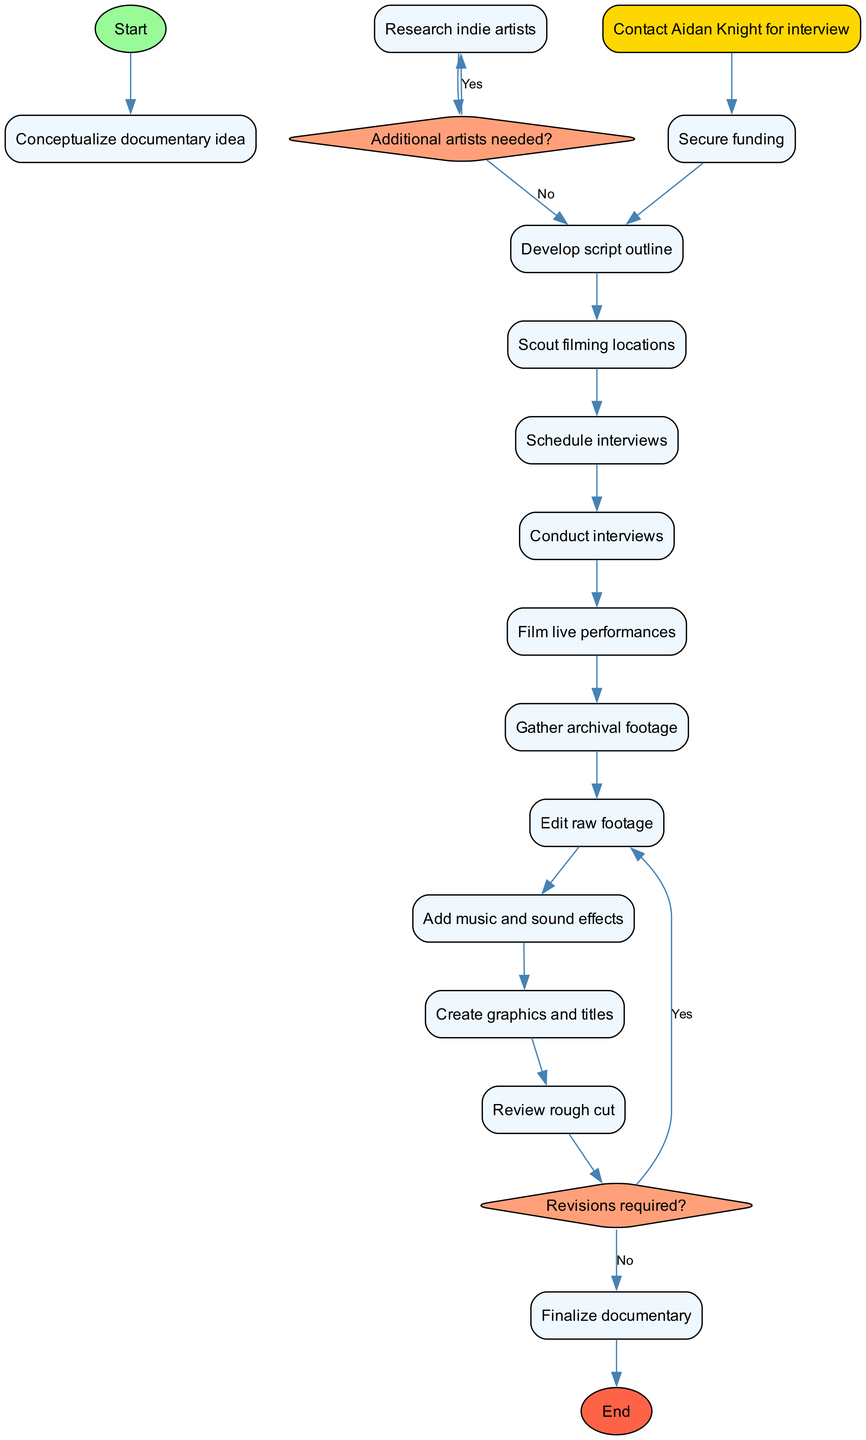What is the first activity listed in the diagram? The diagram starts with the node labeled "Conceptualize documentary idea," indicating that this is the initial step in the process.
Answer: Conceptualize documentary idea How many activities are involved in the process? Counting the activities listed in the diagram, there are a total of 13 distinct activities that need to be executed in order to complete the documentary.
Answer: 13 What decision is made after "Research indie artists"? The decision node that follows "Research indie artists" asks if additional artists are needed, which will determine the next steps based on the response.
Answer: Additional artists needed? Is "Secure funding" a prerequisite for "Develop script outline"? "Secure funding" comes before "Develop script outline" logically in the process flow, but there is no direct edge between them in the diagram, as it flows through a series of other activities.
Answer: No What happens if revisions are required after "Review rough cut"? If revisions are required after "Review rough cut," the process will loop back to the activity "Edit raw footage," allowing the editor to make necessary changes before finalizing the documentary.
Answer: Edit raw footage Which activity is highlighted in the diagram? The activity "Contact Aidan Knight for interview" is specifically highlighted with a different color, drawing attention to its importance in the overall process of making the documentary.
Answer: Contact Aidan Knight for interview What is the final step in the activity diagram? The last node in the flow of activities leads to the final step labeled "Submit to film festivals," which signifies the end of the documentary production process.
Answer: Submit to film festivals How many decision nodes are present in the diagram? There are two decision nodes within the diagram: one regarding whether additional artists are needed and another related to the necessity of revisions.
Answer: 2 What is the last activity before finalizing the documentary? The last activity to be completed before moving on to finalize the documentary is "Review rough cut," which acts as a precursor to the finalization step.
Answer: Review rough cut 